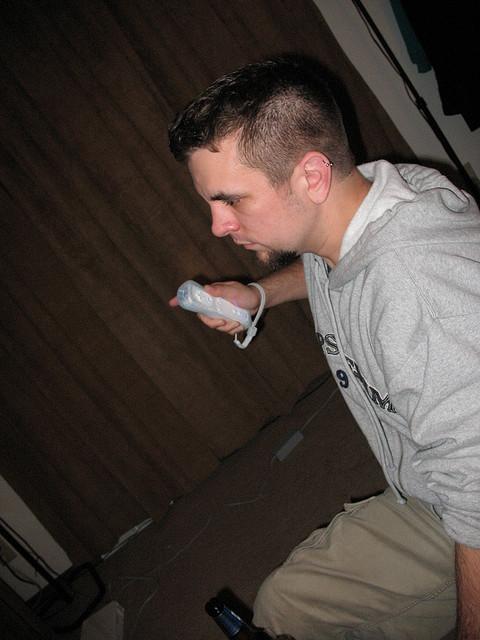Is this person wearing short sleeves?
Concise answer only. No. What is this gentleman doing?
Concise answer only. Playing wii. Was this photo taken at an angle?
Concise answer only. Yes. 